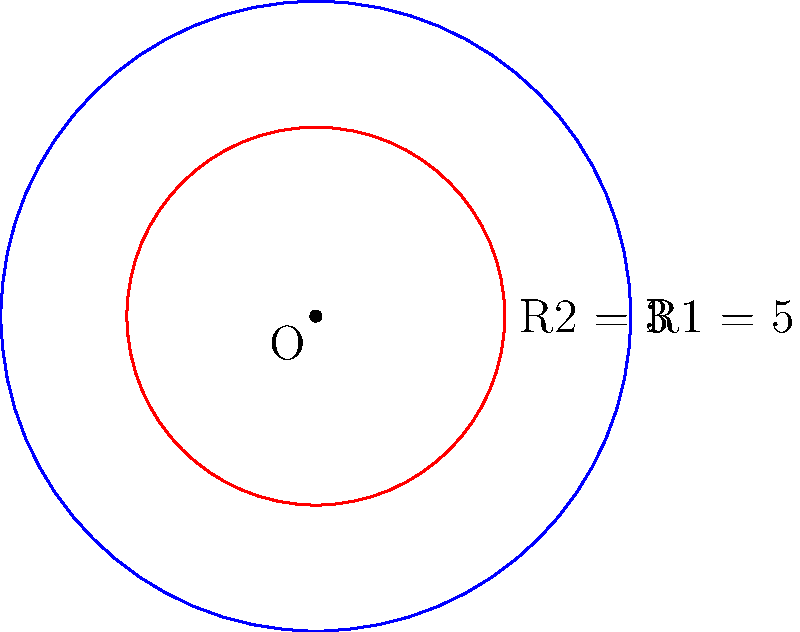In a bioinformatics visualization tool, you're working on displaying circular genomic data. The tool uses concentric circles to represent different layers of information. Given two concentric circles with radii R1 = 5 units and R2 = 3 units, calculate the area of the region between these circles. Round your answer to two decimal places. To find the area between two concentric circles, we need to:

1. Calculate the area of the larger circle (radius R1)
2. Calculate the area of the smaller circle (radius R2)
3. Subtract the area of the smaller circle from the larger circle

Step 1: Area of the larger circle
$$A_1 = \pi R_1^2 = \pi (5)^2 = 25\pi$$

Step 2: Area of the smaller circle
$$A_2 = \pi R_2^2 = \pi (3)^2 = 9\pi$$

Step 3: Area between the circles
$$A = A_1 - A_2 = 25\pi - 9\pi = 16\pi$$

Converting to a decimal and rounding to two places:
$$16\pi \approx 50.27$$

This result represents the area in square units.
Answer: 50.27 square units 